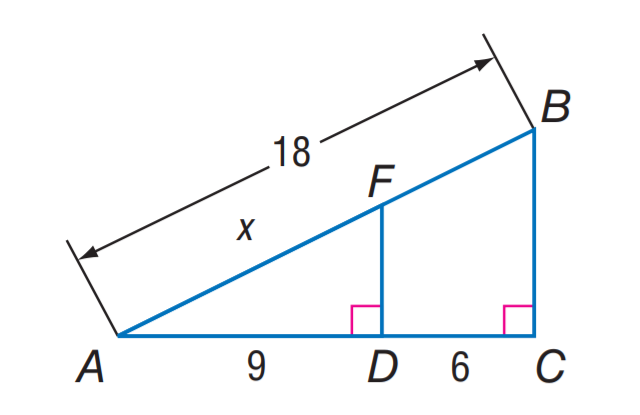Question: Find A F.
Choices:
A. 9
B. 10.8
C. 18
D. 21.6
Answer with the letter. Answer: B 